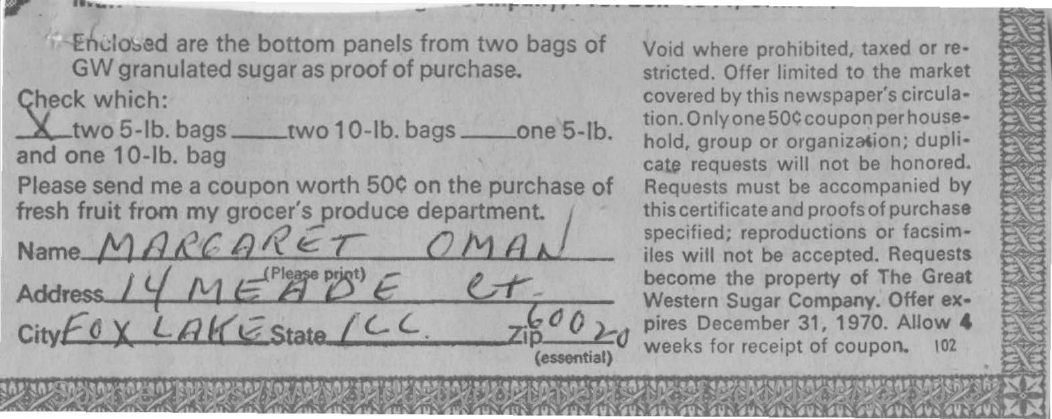Identify some key points in this picture. It is the ZIP code written as 60020. The name written in the form is "Margaret Oman. The city mentioned is called Fox Lake. 